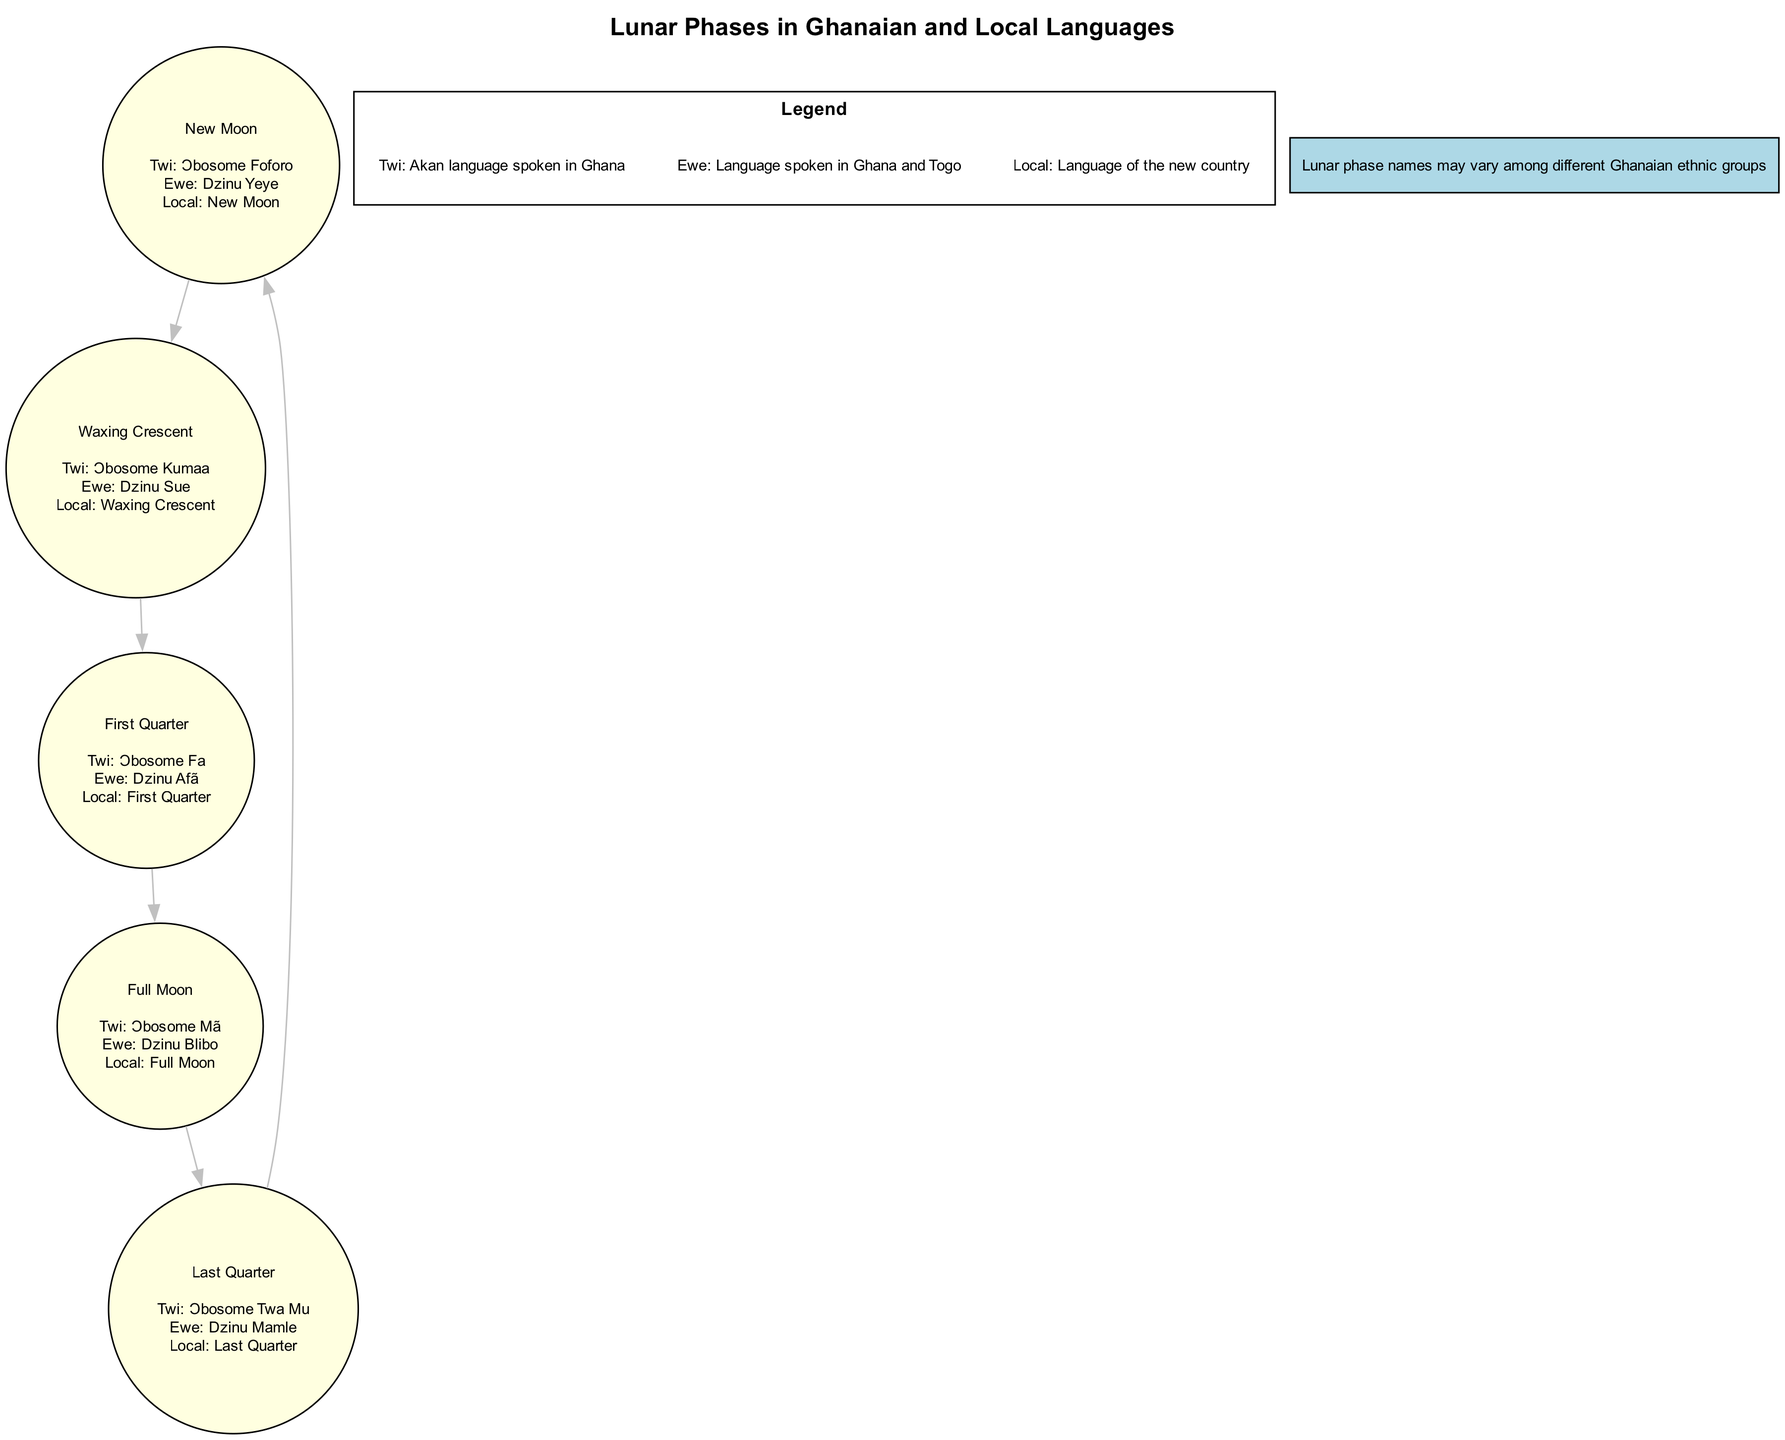What is the Twi name for the Full Moon? The diagram shows that for the lunar phase "Full Moon," the Twi name is "Ɔbosome Mã."
Answer: Ɔbosome Mã How many lunar phases are displayed in the diagram? The diagram features a total of five lunar phases, as there are five nodes connecting them.
Answer: 5 What is the Ewe name for the Last Quarter? According to the diagram, the Ewe name for the "Last Quarter" is "Dzinu Mamle."
Answer: Dzinu Mamle Which lunar phase follows the New Moon? The diagram indicates that the lunar phase following "New Moon" is "Waxing Crescent," as the edges connect these two nodes sequentially.
Answer: Waxing Crescent What is the local name for the First Quarter? The diagram explicitly states that the local name for the "First Quarter" is "First Quarter."
Answer: First Quarter What is the description of the Twi language in the legend? The legend specifies that Twi is described as "Akan language spoken in Ghana," indicating its cultural significance.
Answer: Akan language spoken in Ghana For which lunar phase do the names differ the most in languages? Upon reviewing the names in Twi, Ewe, and local language, the "Full Moon" displays distinct names in all three languages, showcasing the most variation.
Answer: Full Moon How is the Last Quarter represented in Ewe? The diagram shows that in Ewe, the "Last Quarter" is represented by the name "Dzinu Mamle."
Answer: Dzinu Mamle What is the common term for all lunar phases in the local language? Each lunar phase has a corresponding name in the local language, which can be found under each phase label in the diagram. The common term for the phases is simply their English names.
Answer: New Moon, Waxing Crescent, First Quarter, Full Moon, Last Quarter What shape are the nodes representing lunar phases? The diagram specifies that the nodes representing the lunar phases are circular shapes, which is stated in the diagram attributes.
Answer: Circle 